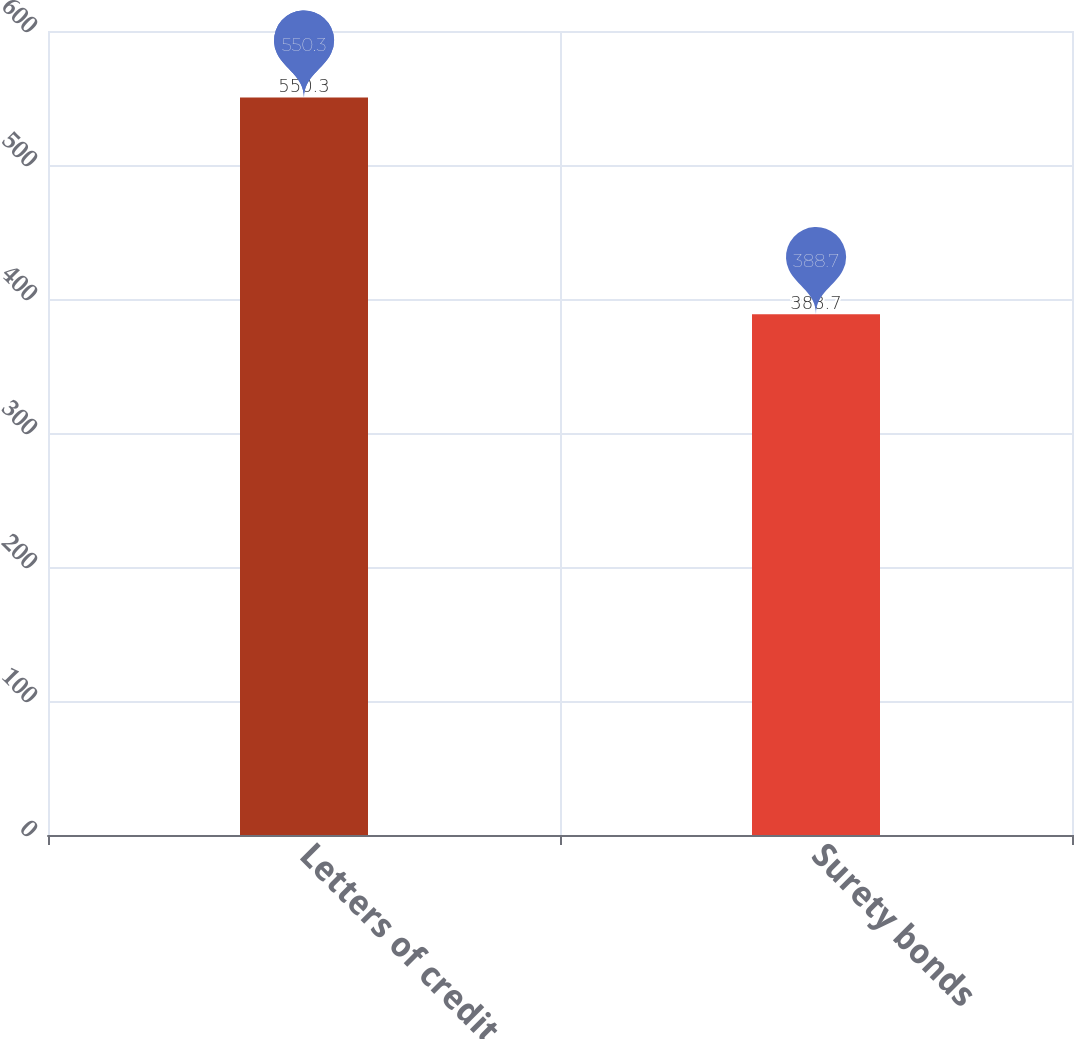<chart> <loc_0><loc_0><loc_500><loc_500><bar_chart><fcel>Letters of credit<fcel>Surety bonds<nl><fcel>550.3<fcel>388.7<nl></chart> 